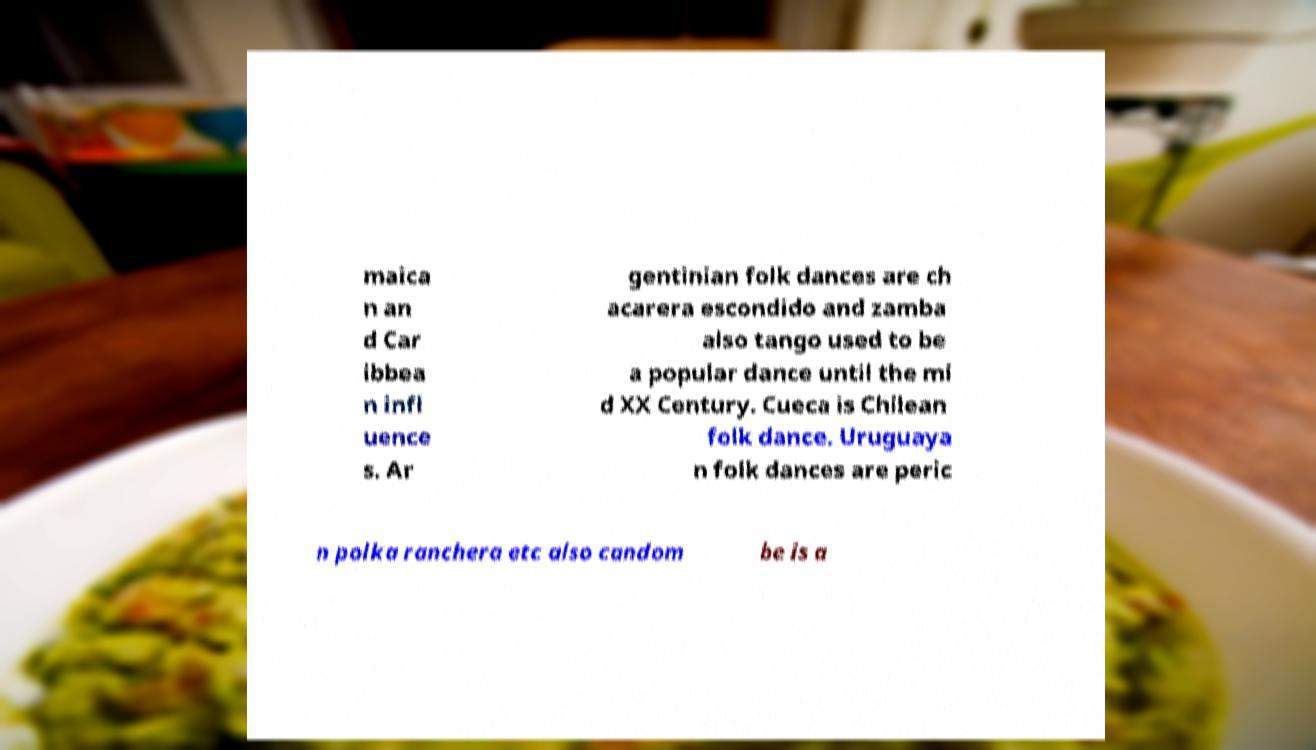Could you assist in decoding the text presented in this image and type it out clearly? maica n an d Car ibbea n infl uence s. Ar gentinian folk dances are ch acarera escondido and zamba also tango used to be a popular dance until the mi d XX Century. Cueca is Chilean folk dance. Uruguaya n folk dances are peric n polka ranchera etc also candom be is a 